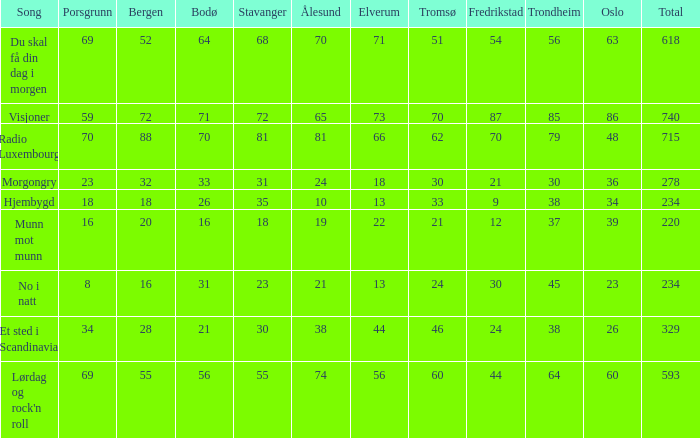When the total score is 740, what is tromso? 70.0. 